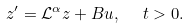<formula> <loc_0><loc_0><loc_500><loc_500>z ^ { \prime } = \mathcal { L } ^ { \alpha } z + B u , \ \ t > 0 .</formula> 